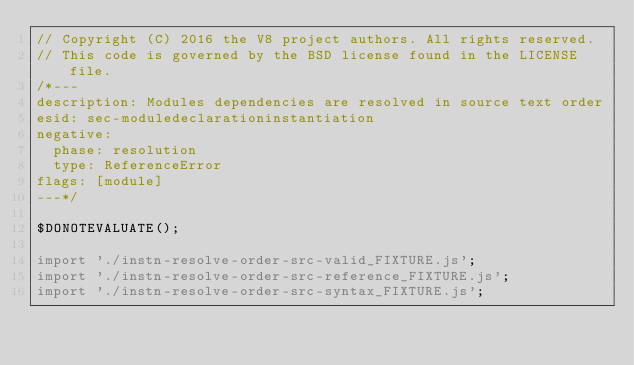Convert code to text. <code><loc_0><loc_0><loc_500><loc_500><_JavaScript_>// Copyright (C) 2016 the V8 project authors. All rights reserved.
// This code is governed by the BSD license found in the LICENSE file.
/*---
description: Modules dependencies are resolved in source text order
esid: sec-moduledeclarationinstantiation
negative:
  phase: resolution
  type: ReferenceError
flags: [module]
---*/

$DONOTEVALUATE();

import './instn-resolve-order-src-valid_FIXTURE.js';
import './instn-resolve-order-src-reference_FIXTURE.js';
import './instn-resolve-order-src-syntax_FIXTURE.js';
</code> 